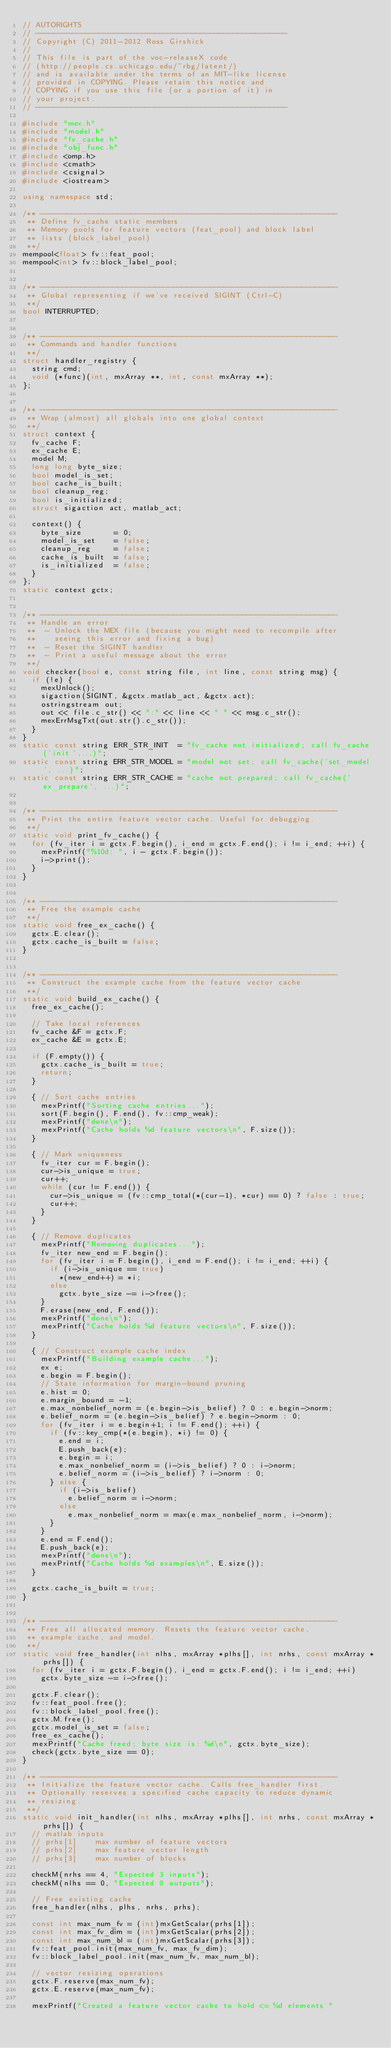<code> <loc_0><loc_0><loc_500><loc_500><_C++_>// AUTORIGHTS
// -------------------------------------------------------
// Copyright (C) 2011-2012 Ross Girshick
// 
// This file is part of the voc-releaseX code
// (http://people.cs.uchicago.edu/~rbg/latent/)
// and is available under the terms of an MIT-like license
// provided in COPYING. Please retain this notice and
// COPYING if you use this file (or a portion of it) in
// your project.
// -------------------------------------------------------

#include "mex.h"
#include "model.h"
#include "fv_cache.h"
#include "obj_func.h"
#include <omp.h>
#include <cmath>
#include <csignal>
#include <iostream>

using namespace std;

/** -----------------------------------------------------------------
 ** Define fv_cache static members
 ** Memory pools for feature vectors (feat_pool) and block label 
 ** lists (block_label_pool)
 **/
mempool<float> fv::feat_pool;
mempool<int> fv::block_label_pool;


/** -----------------------------------------------------------------
 ** Global representing if we've received SIGINT (Ctrl-C)
 **/
bool INTERRUPTED;


/** -----------------------------------------------------------------
 ** Commands and handler functions
 **/
struct handler_registry {
  string cmd;
  void (*func)(int, mxArray **, int, const mxArray **);
};


/** -----------------------------------------------------------------
 ** Wrap (almost) all globals into one global context
 **/
struct context {
  fv_cache F;
  ex_cache E;
  model M;
  long long byte_size;
  bool model_is_set;
  bool cache_is_built;
  bool cleanup_reg;
  bool is_initialized;
  struct sigaction act, matlab_act;

  context() {
    byte_size       = 0;
    model_is_set    = false;
    cleanup_reg     = false;
    cache_is_built  = false;
    is_initialized  = false;
  }
};
static context gctx;


/** -----------------------------------------------------------------
 ** Handle an error
 **  - Unlock the MEX file (because you might need to recompile after 
 **    seeing this error and fixing a bug)
 **  - Reset the SIGINT handler
 **  - Print a useful message about the error
 **/
void checker(bool e, const string file, int line, const string msg) {
  if (!e) {
    mexUnlock();
    sigaction(SIGINT, &gctx.matlab_act, &gctx.act);
    ostringstream out;
    out << file.c_str() << ":" << line << " " << msg.c_str();
    mexErrMsgTxt(out.str().c_str());
  }
}
static const string ERR_STR_INIT  = "fv_cache not initialized; call fv_cache('init',...)";
static const string ERR_STR_MODEL = "model not set; call fv_cache('set_model', ...)";
static const string ERR_STR_CACHE = "cache not prepared; call fv_cache('ex_prepare', ...)";


/** -----------------------------------------------------------------
 ** Print the entire feature vector cache. Useful for debugging.
 **/
static void print_fv_cache() {
  for (fv_iter i = gctx.F.begin(), i_end = gctx.F.end(); i != i_end; ++i) {
    mexPrintf("%10d: ", i - gctx.F.begin());
    i->print();
  }
}


/** -----------------------------------------------------------------
 ** Free the example cache
 **/
static void free_ex_cache() {
  gctx.E.clear();
  gctx.cache_is_built = false;
}


/** -----------------------------------------------------------------
 ** Construct the example cache from the feature vector cache
 **/
static void build_ex_cache() {
  free_ex_cache();

  // Take local references
  fv_cache &F = gctx.F;
  ex_cache &E = gctx.E;

  if (F.empty()) {
    gctx.cache_is_built = true;
    return;
  }

  { // Sort cache entries
    mexPrintf("Sorting cache entries...");
    sort(F.begin(), F.end(), fv::cmp_weak);
    mexPrintf("done\n");
    mexPrintf("Cache holds %d feature vectors\n", F.size());
  }

  { // Mark uniqueness
    fv_iter cur = F.begin();
    cur->is_unique = true;
    cur++;
    while (cur != F.end()) {
      cur->is_unique = (fv::cmp_total(*(cur-1), *cur) == 0) ? false : true;
      cur++;
    }
  }

  { // Remove duplicates
    mexPrintf("Removing duplicates...");
    fv_iter new_end = F.begin();
    for (fv_iter i = F.begin(), i_end = F.end(); i != i_end; ++i) {
      if (i->is_unique == true)
        *(new_end++) = *i;
      else
        gctx.byte_size -= i->free();
    }
    F.erase(new_end, F.end());
    mexPrintf("done\n");
    mexPrintf("Cache holds %d feature vectors\n", F.size());
  }

  { // Construct example cache index
    mexPrintf("Building example cache...");
    ex e;
    e.begin = F.begin();
    // State information for margin-bound pruning
    e.hist = 0;
    e.margin_bound = -1;
    e.max_nonbelief_norm = (e.begin->is_belief) ? 0 : e.begin->norm;
    e.belief_norm = (e.begin->is_belief) ? e.begin->norm : 0;
    for (fv_iter i = e.begin+1; i != F.end(); ++i) {
      if (fv::key_cmp(*(e.begin), *i) != 0) {
        e.end = i;
        E.push_back(e);
        e.begin = i;
        e.max_nonbelief_norm = (i->is_belief) ? 0 : i->norm;
        e.belief_norm = (i->is_belief) ? i->norm : 0;
      } else {
        if (i->is_belief)
          e.belief_norm = i->norm;
        else
          e.max_nonbelief_norm = max(e.max_nonbelief_norm, i->norm);
      }
    }
    e.end = F.end();
    E.push_back(e);
    mexPrintf("done\n");
    mexPrintf("Cache holds %d examples\n", E.size());
  }

  gctx.cache_is_built = true;
}


/** -----------------------------------------------------------------
 ** Free all allocated memory. Resets the feature vector cache, 
 ** example cache, and model.
 **/
static void free_handler(int nlhs, mxArray *plhs[], int nrhs, const mxArray *prhs[]) {
  for (fv_iter i = gctx.F.begin(), i_end = gctx.F.end(); i != i_end; ++i)
    gctx.byte_size -= i->free();

  gctx.F.clear();
  fv::feat_pool.free();
  fv::block_label_pool.free();
  gctx.M.free();
  gctx.model_is_set = false;
  free_ex_cache();
  mexPrintf("Cache freed; byte size is: %d\n", gctx.byte_size);
  check(gctx.byte_size == 0);
}

/** -----------------------------------------------------------------
 ** Initialize the feature vector cache. Calls free_handler first.
 ** Optionally reserves a specified cache capacity to reduce dynamic
 ** resizing.
 **/
static void init_handler(int nlhs, mxArray *plhs[], int nrhs, const mxArray *prhs[]) {
  // matlab inputs
  // prhs[1]    max number of feature vectors
  // prhs[2]    max feature vector length
  // prhs[3]    max number of blocks

  checkM(nrhs == 4, "Expected 3 inputs");
  checkM(nlhs == 0, "Expected 0 outputs");

  // Free existing cache
  free_handler(nlhs, plhs, nrhs, prhs);

  const int max_num_fv = (int)mxGetScalar(prhs[1]);
  const int max_fv_dim = (int)mxGetScalar(prhs[2]);
  const int max_num_bl = (int)mxGetScalar(prhs[3]);
  fv::feat_pool.init(max_num_fv, max_fv_dim);
  fv::block_label_pool.init(max_num_fv, max_num_bl);

  // vector resizing operations
  gctx.F.reserve(max_num_fv);
  gctx.E.reserve(max_num_fv);

  mexPrintf("Created a feature vector cache to hold <= %d elements "</code> 